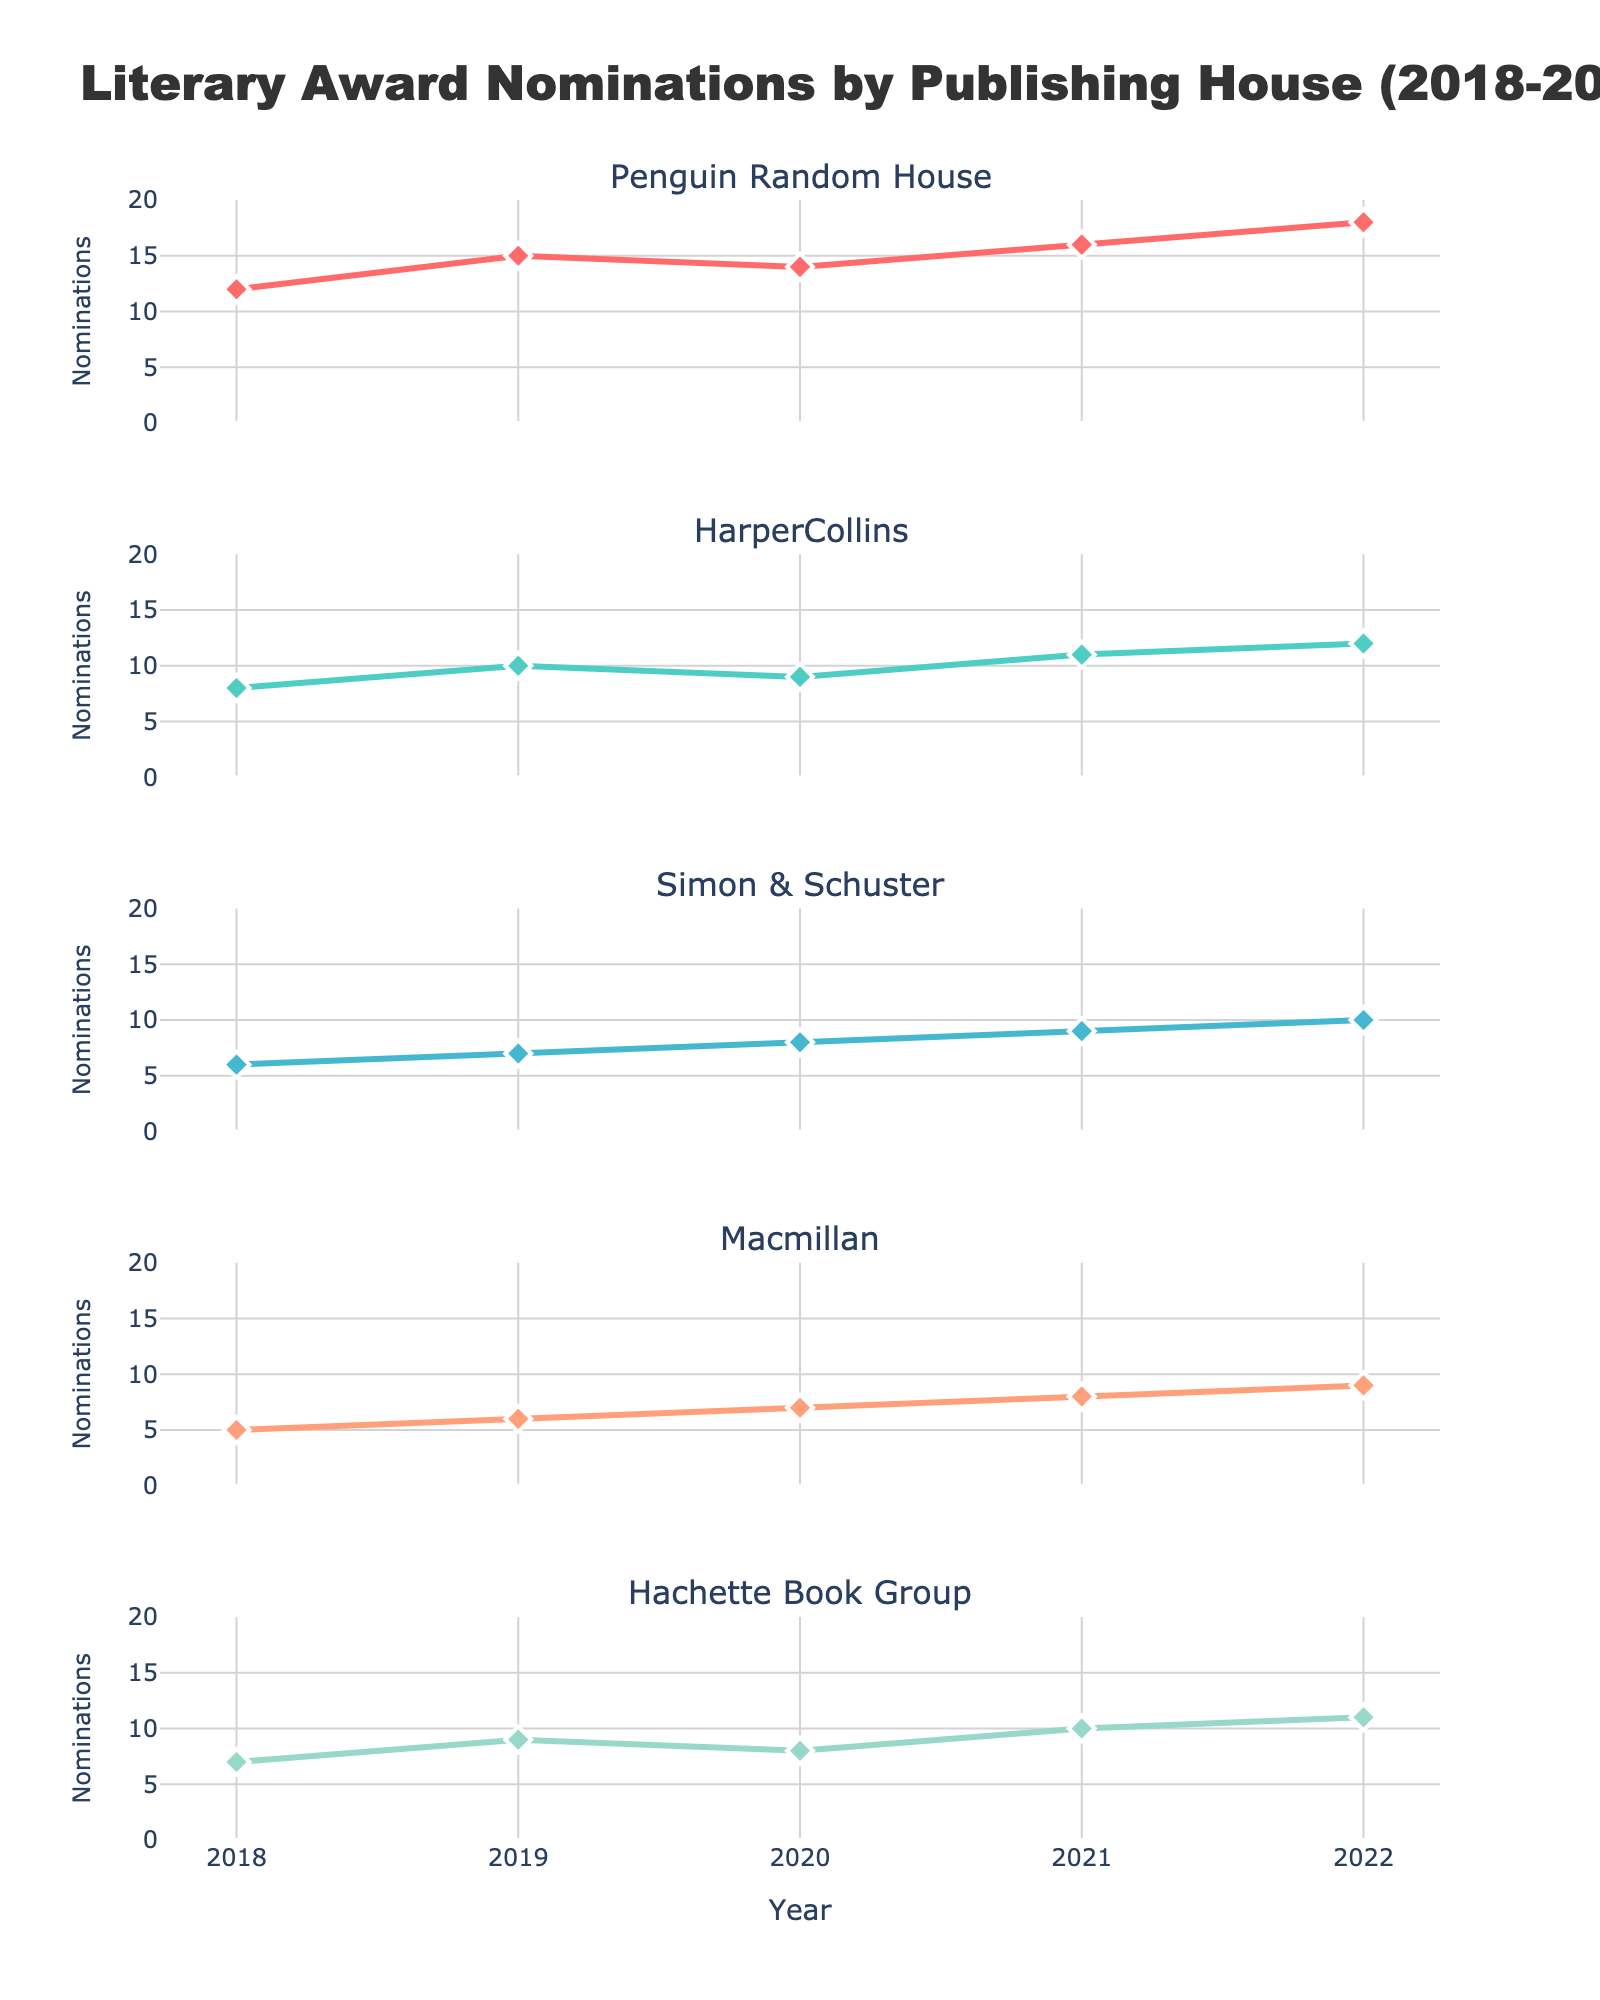What is the title of the figure? The title is usually found at the top of the figure. It summarizes the main theme or subject of the visualization. In this case, the title is: "Literary Award Nominations by Publishing House (2018-2022)".
Answer: Literary Award Nominations by Publishing House (2018-2022) Which publishing house had the highest number of nominations in 2022? Look at the subplot for each publishing house and identify the data point for the year 2022. Compare these values across the subplots. The publishing house with the highest value in 2022 is Penguin Random House with 18 nominations.
Answer: Penguin Random House What is the trend of nominations for Hachette Book Group from 2018 to 2022? Observe the line plot for Hachette Book Group. The line starts at 7 in 2018 and increases each year, reaching 11 in 2022. The trend shows a steady increase in nominations over the 5 years.
Answer: Steady increase How many more nominations did HarperCollins receive in 2022 compared to 2018? Identify the number of nominations HarperCollins received in 2022 and 2018 from the subplot. Subtract the 2018 value (8) from the 2022 value (12). The difference is 4.
Answer: 4 more nominations Which two publishing houses had the closest number of nominations in 2020? Compare the values of nominations for all publishing houses in 2020. Notice that HarperCollins had 9 nominations and Hachette Book Group had 8 nominations, indicating the smallest difference.
Answer: HarperCollins and Hachette Book Group What is the average number of nominations for Macmillan over the five years? Sum the nominations for Macmillan from 2018 to 2022 (5 + 6 + 7 + 8 + 9). The total is 35. Divide this by the 5 years to get the average (35/5).
Answer: 7 Which publishing house showed the most significant increase in nominations from 2018 to 2022? Calculate the difference in nominations from 2018 to 2022 for all publishing houses. Penguin Random House has the largest increase than the others (18 - 12 = 6).
Answer: Penguin Random House Between Simon & Schuster and Macmillan, which publishing house had more nominations in 2021? Compare the values for both publishing houses in the subplot for the year 2021. Simon & Schuster had 9 nominations and Macmillan had 8. Simon & Schuster had more nominations.
Answer: Simon & Schuster How many nominations did Simon & Schuster have in 2020, and how does it compare with the previous year? Look at the number of nominations for Simon & Schuster in 2020 and 2019. In 2020, Simon & Schuster had 8 and in 2019, they had 7. Comparing these values, Simon & Schuster had 1 more nomination in 2020 than in 2019.
Answer: 8 nominations, 1 more How do the trends of Penguin Random House and Hachette Book Group differ over the years? Observe the line plots for both Penguin Random House and Hachette Book Group. Penguin Random House has a consistent increase each year, with the most considerable rise among all houses. Hachette Book Group also shows an increase but at a more modest, steady rate.
Answer: Penguin Random House shows a steep increase, Hachette Book Group shows a steady increase 